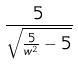Convert formula to latex. <formula><loc_0><loc_0><loc_500><loc_500>\frac { 5 } { \sqrt { \frac { 5 } { w ^ { 2 } } - 5 } }</formula> 